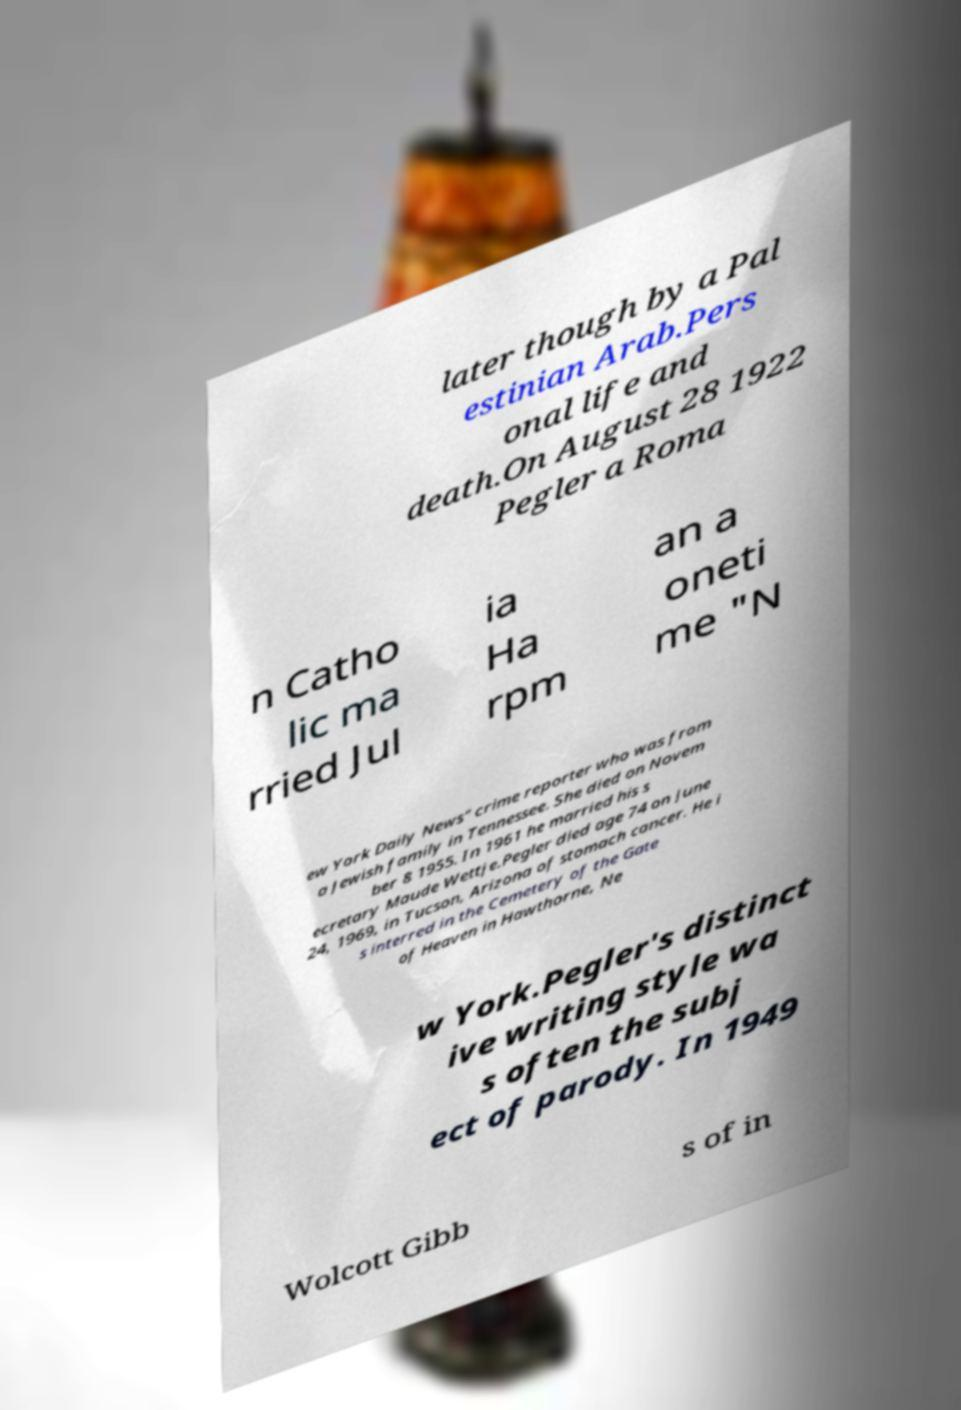Could you extract and type out the text from this image? later though by a Pal estinian Arab.Pers onal life and death.On August 28 1922 Pegler a Roma n Catho lic ma rried Jul ia Ha rpm an a oneti me "N ew York Daily News" crime reporter who was from a Jewish family in Tennessee. She died on Novem ber 8 1955. In 1961 he married his s ecretary Maude Wettje.Pegler died age 74 on June 24, 1969, in Tucson, Arizona of stomach cancer. He i s interred in the Cemetery of the Gate of Heaven in Hawthorne, Ne w York.Pegler's distinct ive writing style wa s often the subj ect of parody. In 1949 Wolcott Gibb s of in 